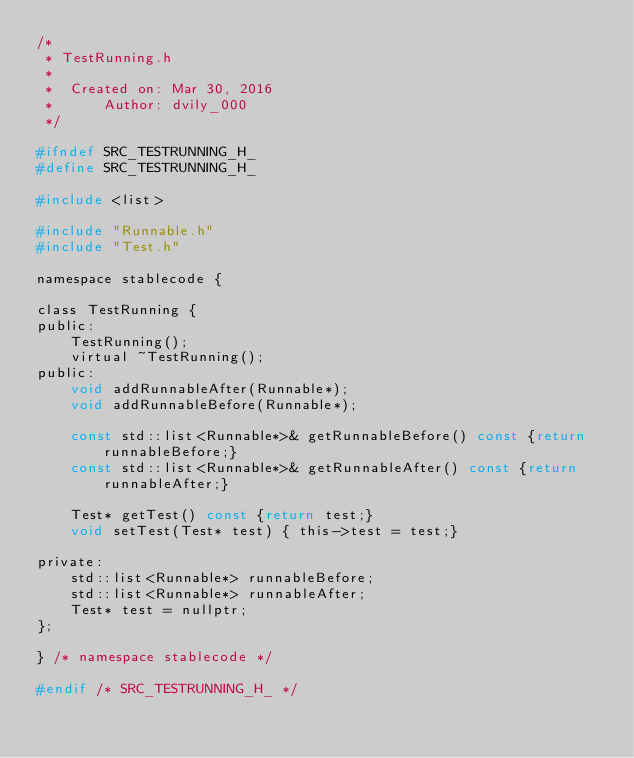<code> <loc_0><loc_0><loc_500><loc_500><_C_>/*
 * TestRunning.h
 *
 *  Created on: Mar 30, 2016
 *      Author: dvily_000
 */

#ifndef SRC_TESTRUNNING_H_
#define SRC_TESTRUNNING_H_

#include <list>

#include "Runnable.h"
#include "Test.h"

namespace stablecode {

class TestRunning {
public:
	TestRunning();
	virtual ~TestRunning();
public:
	void addRunnableAfter(Runnable*);
	void addRunnableBefore(Runnable*);

	const std::list<Runnable*>& getRunnableBefore() const {return runnableBefore;}
	const std::list<Runnable*>& getRunnableAfter() const {return runnableAfter;}

	Test* getTest() const {return test;}
	void setTest(Test* test) { this->test = test;}

private:
	std::list<Runnable*> runnableBefore;
	std::list<Runnable*> runnableAfter;
	Test* test = nullptr;
};

} /* namespace stablecode */

#endif /* SRC_TESTRUNNING_H_ */
</code> 